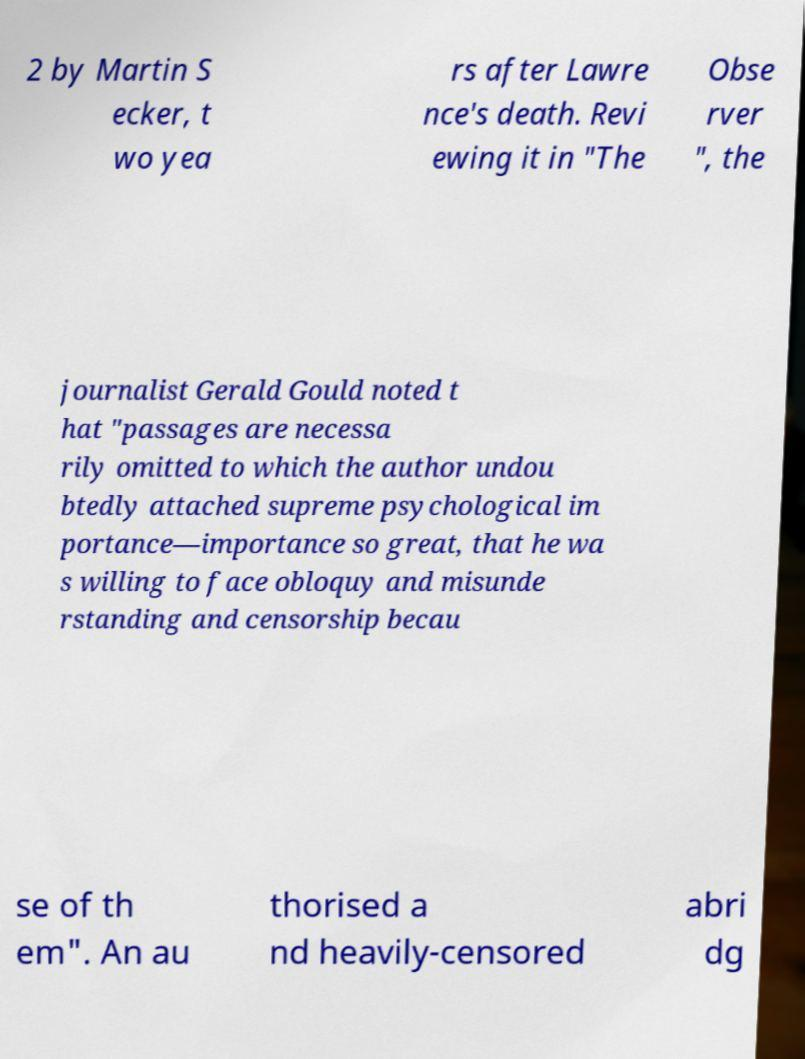Can you accurately transcribe the text from the provided image for me? 2 by Martin S ecker, t wo yea rs after Lawre nce's death. Revi ewing it in "The Obse rver ", the journalist Gerald Gould noted t hat "passages are necessa rily omitted to which the author undou btedly attached supreme psychological im portance—importance so great, that he wa s willing to face obloquy and misunde rstanding and censorship becau se of th em". An au thorised a nd heavily-censored abri dg 